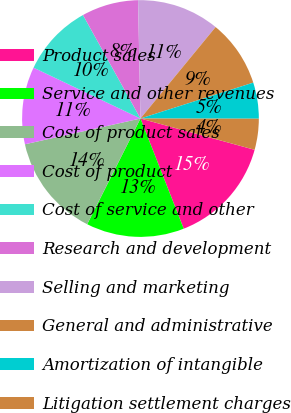Convert chart. <chart><loc_0><loc_0><loc_500><loc_500><pie_chart><fcel>Product sales<fcel>Service and other revenues<fcel>Cost of product sales<fcel>Cost of product<fcel>Cost of service and other<fcel>Research and development<fcel>Selling and marketing<fcel>General and administrative<fcel>Amortization of intangible<fcel>Litigation settlement charges<nl><fcel>14.79%<fcel>13.38%<fcel>14.08%<fcel>10.56%<fcel>9.86%<fcel>7.75%<fcel>11.27%<fcel>9.15%<fcel>4.93%<fcel>4.23%<nl></chart> 